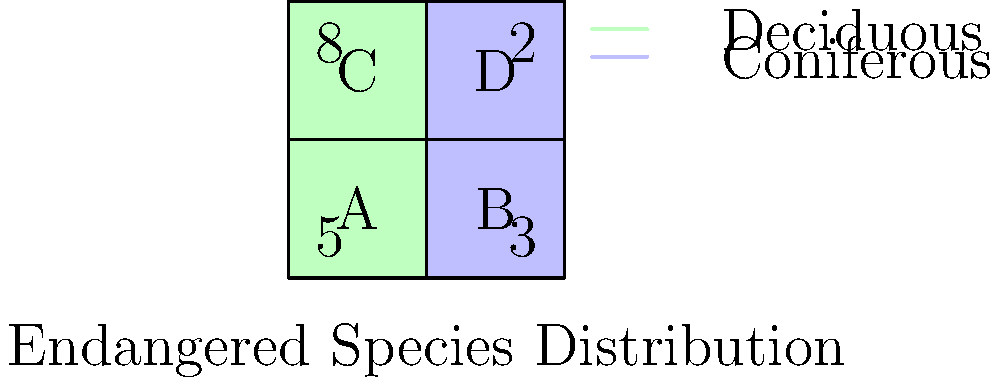Given the map showing the distribution of endangered species across different forest regions, what is the minimum number of regions that need to be allocated for logging to ensure at least 70% of the total endangered species population remains protected? To solve this problem, we need to follow these steps:

1. Calculate the total number of endangered species across all regions:
   Region A: 5
   Region B: 3
   Region C: 8
   Region D: 2
   Total: 5 + 3 + 8 + 2 = 18 endangered species

2. Calculate 70% of the total population:
   70% of 18 = 0.7 × 18 = 12.6 species

3. We need to protect at least 13 species (rounding up) to meet the 70% requirement.

4. Analyze the regions in descending order of species count:
   C (8 species), A (5 species), B (3 species), D (2 species)

5. Start allocating protected regions:
   - Protect C: 8 species (not enough)
   - Protect C and A: 8 + 5 = 13 species (meets the requirement)

6. Count the number of protected regions: 2 (C and A)

Therefore, we need to allocate a minimum of 2 regions (C and A) for protection to ensure at least 70% of the endangered species population remains protected. This leaves 2 regions (B and D) available for logging.
Answer: 2 regions 